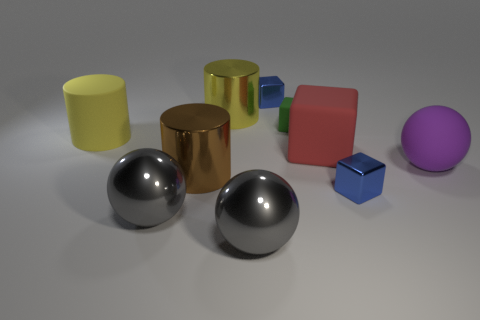What shape is the big yellow object behind the small green matte cube?
Offer a terse response. Cylinder. What number of yellow metallic things have the same size as the brown thing?
Offer a terse response. 1. There is a metallic cylinder behind the tiny green rubber object; does it have the same color as the large matte cylinder?
Keep it short and to the point. Yes. There is a thing that is on the left side of the large brown metal object and behind the big red object; what is its material?
Make the answer very short. Rubber. Is the number of tiny metal cubes greater than the number of small purple metallic things?
Ensure brevity in your answer.  Yes. There is a large rubber object on the left side of the large metallic thing to the right of the yellow cylinder that is behind the green thing; what color is it?
Your response must be concise. Yellow. Are the tiny object behind the large yellow metallic cylinder and the green thing made of the same material?
Offer a terse response. No. Is there another cube that has the same color as the big matte block?
Keep it short and to the point. No. Is there a red cylinder?
Make the answer very short. No. There is a shiny block in front of the purple matte thing; is it the same size as the tiny green rubber block?
Give a very brief answer. Yes. 